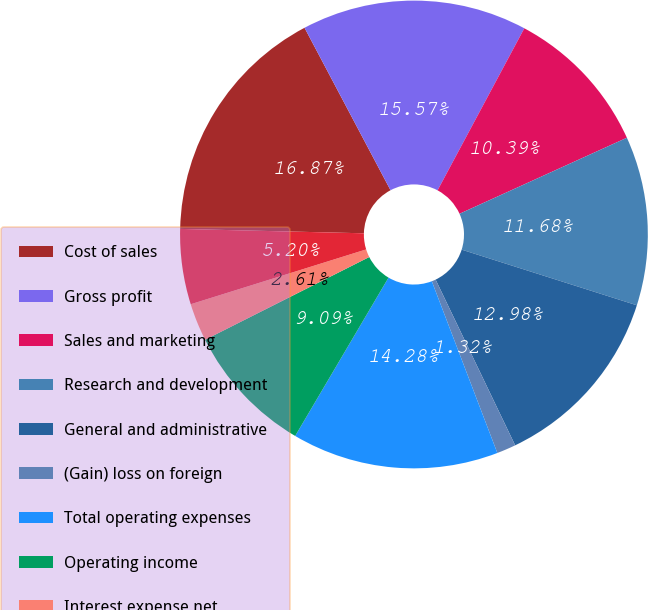Convert chart. <chart><loc_0><loc_0><loc_500><loc_500><pie_chart><fcel>Cost of sales<fcel>Gross profit<fcel>Sales and marketing<fcel>Research and development<fcel>General and administrative<fcel>(Gain) loss on foreign<fcel>Total operating expenses<fcel>Operating income<fcel>Interest expense net<fcel>Other income (expense) net<nl><fcel>16.87%<fcel>15.57%<fcel>10.39%<fcel>11.68%<fcel>12.98%<fcel>1.32%<fcel>14.28%<fcel>9.09%<fcel>2.61%<fcel>5.2%<nl></chart> 